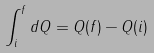Convert formula to latex. <formula><loc_0><loc_0><loc_500><loc_500>\int _ { i } ^ { f } d Q = Q ( f ) - Q ( i )</formula> 